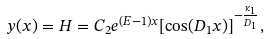<formula> <loc_0><loc_0><loc_500><loc_500>y ( x ) = H = C _ { 2 } e ^ { ( E - 1 ) x } [ \cos ( D _ { 1 } x ) ] ^ { - \frac { \kappa _ { 1 } } { D _ { 1 } } } ,</formula> 